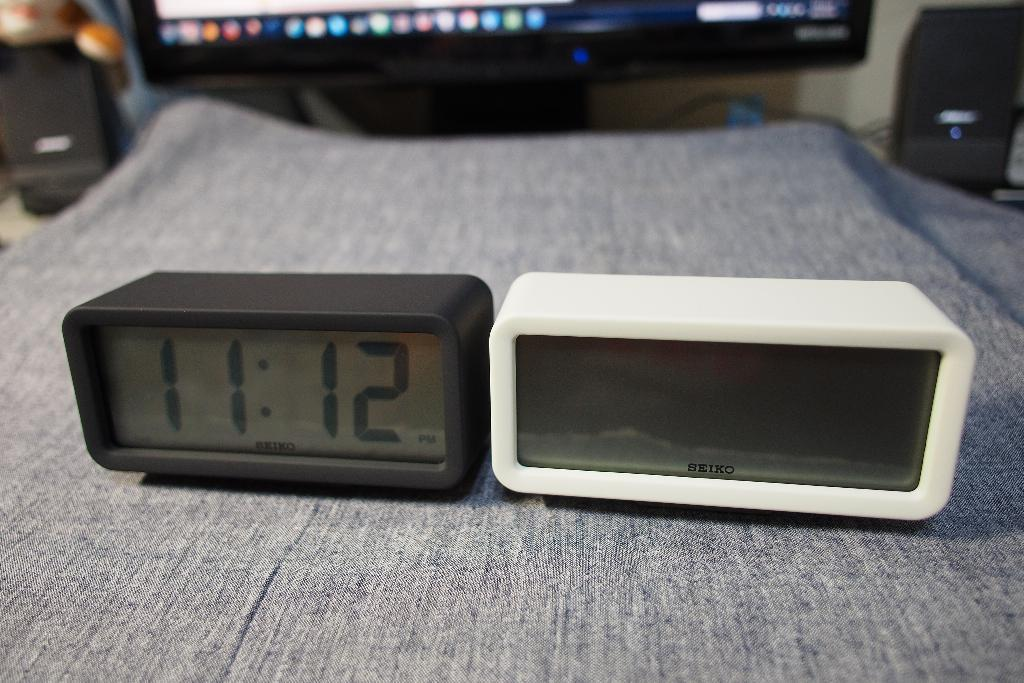<image>
Summarize the visual content of the image. A black alarm clock reading 11:12 sits by a white alarm clock that does not have a time displayed. 